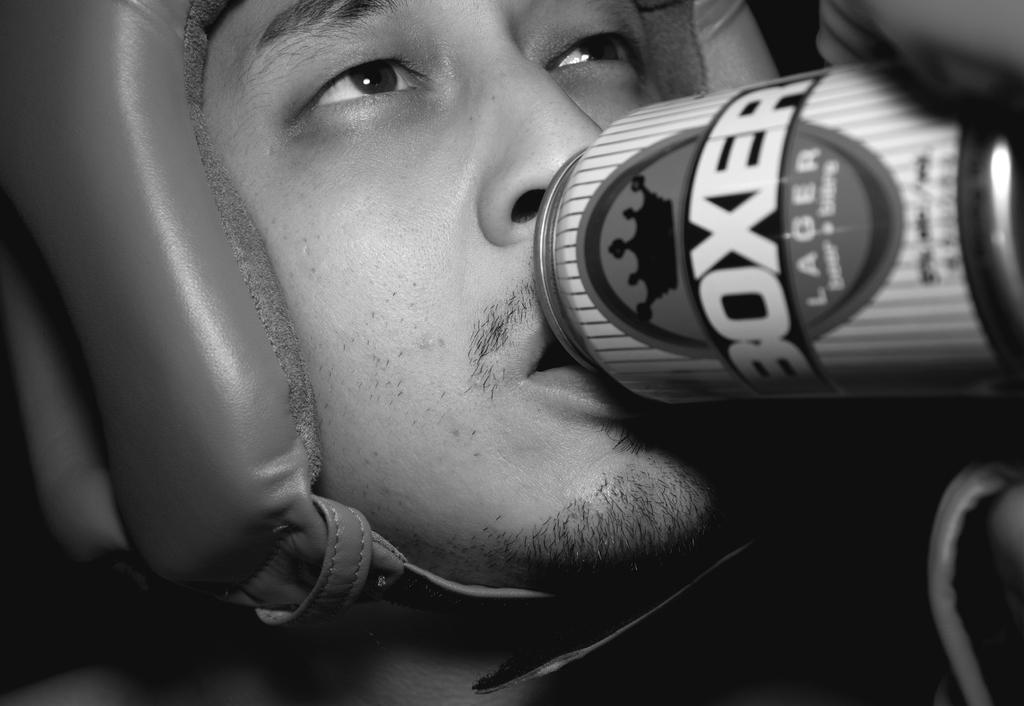<image>
Offer a succinct explanation of the picture presented. A person with a can of Boxer lager up to his mouth. 